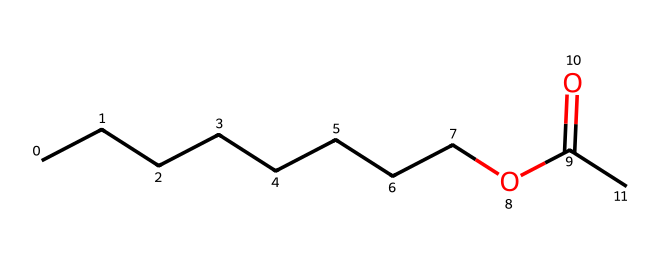How many carbon atoms are in octyl acetate? The SMILES representation shows a long chain of carbon atoms. Counting the 'C's in the chain and the one in the carboxylate group indicates there are 9 carbon atoms in total.
Answer: 9 What type of functional group is present? The structure includes a carbonyl group (C=O) followed by an oxygen atom linked to an alkyl chain, which characterizes it as an ester.
Answer: ester How many oxygen atoms are in octyl acetate? From the structure, there are 2 oxygen atoms: one in the carbonyl (C=O) and one in the ether link (C-O).
Answer: 2 What is the general formula for esters based on this structure? Esters typically have the general formula RCOOR', where 'R' is the hydrocarbon chain, and 'R'' is usually another hydrocarbon group or hydrogen. In this case, R is the octyl group and R' is derived from acetic acid.
Answer: RCOOR' What does the structure suggest about the scent of octyl acetate? This structure, with its long hydrocarbon chain and the ester functional group, is associated with fruity or orangey scents, which is typical for esters used in air fresheners.
Answer: fruity How many hydrogen atoms are likely in octyl acetate? Using the general formula for alkanes (C_nH_(2n+2)) and taking into account the two oxygen atoms in the ester, octyl acetate has 18 hydrogen atoms (from C9H20 - 2).
Answer: 18 